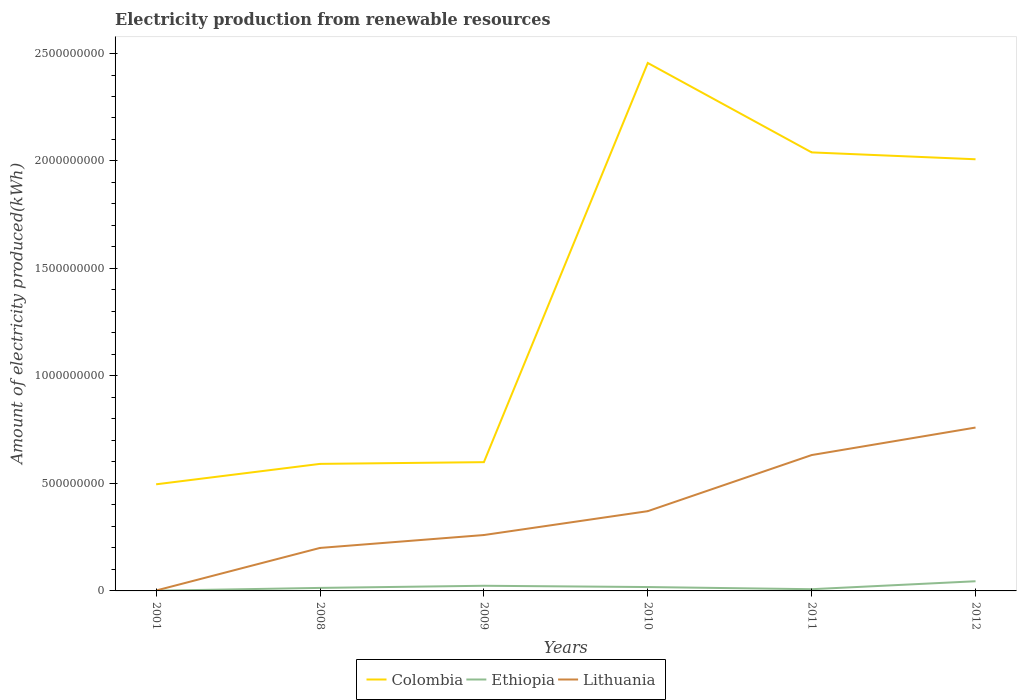How many different coloured lines are there?
Offer a terse response. 3. Does the line corresponding to Ethiopia intersect with the line corresponding to Colombia?
Give a very brief answer. No. Is the number of lines equal to the number of legend labels?
Keep it short and to the point. Yes. Across all years, what is the maximum amount of electricity produced in Colombia?
Your answer should be very brief. 4.96e+08. In which year was the amount of electricity produced in Lithuania maximum?
Offer a terse response. 2001. What is the total amount of electricity produced in Colombia in the graph?
Make the answer very short. -9.50e+07. What is the difference between the highest and the second highest amount of electricity produced in Lithuania?
Ensure brevity in your answer.  7.58e+08. What is the difference between the highest and the lowest amount of electricity produced in Lithuania?
Make the answer very short. 3. Is the amount of electricity produced in Ethiopia strictly greater than the amount of electricity produced in Lithuania over the years?
Keep it short and to the point. Yes. How many years are there in the graph?
Provide a short and direct response. 6. Are the values on the major ticks of Y-axis written in scientific E-notation?
Provide a short and direct response. No. How many legend labels are there?
Your answer should be very brief. 3. How are the legend labels stacked?
Ensure brevity in your answer.  Horizontal. What is the title of the graph?
Keep it short and to the point. Electricity production from renewable resources. Does "Paraguay" appear as one of the legend labels in the graph?
Keep it short and to the point. No. What is the label or title of the Y-axis?
Your answer should be very brief. Amount of electricity produced(kWh). What is the Amount of electricity produced(kWh) in Colombia in 2001?
Offer a very short reply. 4.96e+08. What is the Amount of electricity produced(kWh) of Ethiopia in 2001?
Your answer should be very brief. 1.00e+06. What is the Amount of electricity produced(kWh) in Lithuania in 2001?
Your answer should be very brief. 2.00e+06. What is the Amount of electricity produced(kWh) in Colombia in 2008?
Provide a succinct answer. 5.91e+08. What is the Amount of electricity produced(kWh) in Ethiopia in 2008?
Your answer should be compact. 1.40e+07. What is the Amount of electricity produced(kWh) in Lithuania in 2008?
Ensure brevity in your answer.  2.00e+08. What is the Amount of electricity produced(kWh) in Colombia in 2009?
Provide a short and direct response. 5.99e+08. What is the Amount of electricity produced(kWh) of Ethiopia in 2009?
Offer a terse response. 2.40e+07. What is the Amount of electricity produced(kWh) of Lithuania in 2009?
Offer a terse response. 2.60e+08. What is the Amount of electricity produced(kWh) of Colombia in 2010?
Your answer should be compact. 2.46e+09. What is the Amount of electricity produced(kWh) of Ethiopia in 2010?
Provide a succinct answer. 1.80e+07. What is the Amount of electricity produced(kWh) of Lithuania in 2010?
Your response must be concise. 3.71e+08. What is the Amount of electricity produced(kWh) in Colombia in 2011?
Provide a succinct answer. 2.04e+09. What is the Amount of electricity produced(kWh) of Lithuania in 2011?
Keep it short and to the point. 6.32e+08. What is the Amount of electricity produced(kWh) of Colombia in 2012?
Give a very brief answer. 2.01e+09. What is the Amount of electricity produced(kWh) of Ethiopia in 2012?
Provide a succinct answer. 4.50e+07. What is the Amount of electricity produced(kWh) of Lithuania in 2012?
Your response must be concise. 7.60e+08. Across all years, what is the maximum Amount of electricity produced(kWh) in Colombia?
Provide a short and direct response. 2.46e+09. Across all years, what is the maximum Amount of electricity produced(kWh) in Ethiopia?
Keep it short and to the point. 4.50e+07. Across all years, what is the maximum Amount of electricity produced(kWh) in Lithuania?
Your answer should be very brief. 7.60e+08. Across all years, what is the minimum Amount of electricity produced(kWh) of Colombia?
Keep it short and to the point. 4.96e+08. Across all years, what is the minimum Amount of electricity produced(kWh) of Ethiopia?
Your answer should be compact. 1.00e+06. What is the total Amount of electricity produced(kWh) in Colombia in the graph?
Offer a terse response. 8.19e+09. What is the total Amount of electricity produced(kWh) in Ethiopia in the graph?
Give a very brief answer. 1.10e+08. What is the total Amount of electricity produced(kWh) in Lithuania in the graph?
Provide a short and direct response. 2.22e+09. What is the difference between the Amount of electricity produced(kWh) of Colombia in 2001 and that in 2008?
Offer a very short reply. -9.50e+07. What is the difference between the Amount of electricity produced(kWh) of Ethiopia in 2001 and that in 2008?
Your answer should be compact. -1.30e+07. What is the difference between the Amount of electricity produced(kWh) in Lithuania in 2001 and that in 2008?
Your answer should be very brief. -1.98e+08. What is the difference between the Amount of electricity produced(kWh) in Colombia in 2001 and that in 2009?
Provide a succinct answer. -1.03e+08. What is the difference between the Amount of electricity produced(kWh) in Ethiopia in 2001 and that in 2009?
Make the answer very short. -2.30e+07. What is the difference between the Amount of electricity produced(kWh) in Lithuania in 2001 and that in 2009?
Give a very brief answer. -2.58e+08. What is the difference between the Amount of electricity produced(kWh) of Colombia in 2001 and that in 2010?
Provide a short and direct response. -1.96e+09. What is the difference between the Amount of electricity produced(kWh) in Ethiopia in 2001 and that in 2010?
Provide a short and direct response. -1.70e+07. What is the difference between the Amount of electricity produced(kWh) in Lithuania in 2001 and that in 2010?
Provide a succinct answer. -3.69e+08. What is the difference between the Amount of electricity produced(kWh) of Colombia in 2001 and that in 2011?
Provide a short and direct response. -1.54e+09. What is the difference between the Amount of electricity produced(kWh) of Ethiopia in 2001 and that in 2011?
Ensure brevity in your answer.  -7.00e+06. What is the difference between the Amount of electricity produced(kWh) in Lithuania in 2001 and that in 2011?
Provide a short and direct response. -6.30e+08. What is the difference between the Amount of electricity produced(kWh) in Colombia in 2001 and that in 2012?
Ensure brevity in your answer.  -1.51e+09. What is the difference between the Amount of electricity produced(kWh) of Ethiopia in 2001 and that in 2012?
Ensure brevity in your answer.  -4.40e+07. What is the difference between the Amount of electricity produced(kWh) of Lithuania in 2001 and that in 2012?
Give a very brief answer. -7.58e+08. What is the difference between the Amount of electricity produced(kWh) of Colombia in 2008 and that in 2009?
Make the answer very short. -8.00e+06. What is the difference between the Amount of electricity produced(kWh) of Ethiopia in 2008 and that in 2009?
Your response must be concise. -1.00e+07. What is the difference between the Amount of electricity produced(kWh) of Lithuania in 2008 and that in 2009?
Provide a short and direct response. -6.00e+07. What is the difference between the Amount of electricity produced(kWh) of Colombia in 2008 and that in 2010?
Offer a very short reply. -1.86e+09. What is the difference between the Amount of electricity produced(kWh) of Lithuania in 2008 and that in 2010?
Offer a very short reply. -1.71e+08. What is the difference between the Amount of electricity produced(kWh) in Colombia in 2008 and that in 2011?
Keep it short and to the point. -1.45e+09. What is the difference between the Amount of electricity produced(kWh) of Lithuania in 2008 and that in 2011?
Offer a terse response. -4.32e+08. What is the difference between the Amount of electricity produced(kWh) in Colombia in 2008 and that in 2012?
Offer a terse response. -1.42e+09. What is the difference between the Amount of electricity produced(kWh) of Ethiopia in 2008 and that in 2012?
Your answer should be compact. -3.10e+07. What is the difference between the Amount of electricity produced(kWh) in Lithuania in 2008 and that in 2012?
Give a very brief answer. -5.60e+08. What is the difference between the Amount of electricity produced(kWh) in Colombia in 2009 and that in 2010?
Provide a short and direct response. -1.86e+09. What is the difference between the Amount of electricity produced(kWh) in Lithuania in 2009 and that in 2010?
Provide a short and direct response. -1.11e+08. What is the difference between the Amount of electricity produced(kWh) of Colombia in 2009 and that in 2011?
Make the answer very short. -1.44e+09. What is the difference between the Amount of electricity produced(kWh) of Ethiopia in 2009 and that in 2011?
Offer a terse response. 1.60e+07. What is the difference between the Amount of electricity produced(kWh) in Lithuania in 2009 and that in 2011?
Your answer should be very brief. -3.72e+08. What is the difference between the Amount of electricity produced(kWh) in Colombia in 2009 and that in 2012?
Offer a terse response. -1.41e+09. What is the difference between the Amount of electricity produced(kWh) in Ethiopia in 2009 and that in 2012?
Offer a terse response. -2.10e+07. What is the difference between the Amount of electricity produced(kWh) in Lithuania in 2009 and that in 2012?
Ensure brevity in your answer.  -5.00e+08. What is the difference between the Amount of electricity produced(kWh) of Colombia in 2010 and that in 2011?
Your answer should be very brief. 4.16e+08. What is the difference between the Amount of electricity produced(kWh) in Lithuania in 2010 and that in 2011?
Your response must be concise. -2.61e+08. What is the difference between the Amount of electricity produced(kWh) of Colombia in 2010 and that in 2012?
Offer a terse response. 4.48e+08. What is the difference between the Amount of electricity produced(kWh) of Ethiopia in 2010 and that in 2012?
Ensure brevity in your answer.  -2.70e+07. What is the difference between the Amount of electricity produced(kWh) of Lithuania in 2010 and that in 2012?
Offer a terse response. -3.89e+08. What is the difference between the Amount of electricity produced(kWh) of Colombia in 2011 and that in 2012?
Give a very brief answer. 3.20e+07. What is the difference between the Amount of electricity produced(kWh) in Ethiopia in 2011 and that in 2012?
Your response must be concise. -3.70e+07. What is the difference between the Amount of electricity produced(kWh) of Lithuania in 2011 and that in 2012?
Your answer should be compact. -1.28e+08. What is the difference between the Amount of electricity produced(kWh) of Colombia in 2001 and the Amount of electricity produced(kWh) of Ethiopia in 2008?
Give a very brief answer. 4.82e+08. What is the difference between the Amount of electricity produced(kWh) in Colombia in 2001 and the Amount of electricity produced(kWh) in Lithuania in 2008?
Offer a very short reply. 2.96e+08. What is the difference between the Amount of electricity produced(kWh) in Ethiopia in 2001 and the Amount of electricity produced(kWh) in Lithuania in 2008?
Make the answer very short. -1.99e+08. What is the difference between the Amount of electricity produced(kWh) in Colombia in 2001 and the Amount of electricity produced(kWh) in Ethiopia in 2009?
Give a very brief answer. 4.72e+08. What is the difference between the Amount of electricity produced(kWh) in Colombia in 2001 and the Amount of electricity produced(kWh) in Lithuania in 2009?
Your answer should be very brief. 2.36e+08. What is the difference between the Amount of electricity produced(kWh) in Ethiopia in 2001 and the Amount of electricity produced(kWh) in Lithuania in 2009?
Give a very brief answer. -2.59e+08. What is the difference between the Amount of electricity produced(kWh) of Colombia in 2001 and the Amount of electricity produced(kWh) of Ethiopia in 2010?
Make the answer very short. 4.78e+08. What is the difference between the Amount of electricity produced(kWh) of Colombia in 2001 and the Amount of electricity produced(kWh) of Lithuania in 2010?
Your answer should be compact. 1.25e+08. What is the difference between the Amount of electricity produced(kWh) in Ethiopia in 2001 and the Amount of electricity produced(kWh) in Lithuania in 2010?
Your answer should be compact. -3.70e+08. What is the difference between the Amount of electricity produced(kWh) of Colombia in 2001 and the Amount of electricity produced(kWh) of Ethiopia in 2011?
Your response must be concise. 4.88e+08. What is the difference between the Amount of electricity produced(kWh) in Colombia in 2001 and the Amount of electricity produced(kWh) in Lithuania in 2011?
Ensure brevity in your answer.  -1.36e+08. What is the difference between the Amount of electricity produced(kWh) of Ethiopia in 2001 and the Amount of electricity produced(kWh) of Lithuania in 2011?
Ensure brevity in your answer.  -6.31e+08. What is the difference between the Amount of electricity produced(kWh) of Colombia in 2001 and the Amount of electricity produced(kWh) of Ethiopia in 2012?
Give a very brief answer. 4.51e+08. What is the difference between the Amount of electricity produced(kWh) of Colombia in 2001 and the Amount of electricity produced(kWh) of Lithuania in 2012?
Your response must be concise. -2.64e+08. What is the difference between the Amount of electricity produced(kWh) of Ethiopia in 2001 and the Amount of electricity produced(kWh) of Lithuania in 2012?
Provide a succinct answer. -7.59e+08. What is the difference between the Amount of electricity produced(kWh) in Colombia in 2008 and the Amount of electricity produced(kWh) in Ethiopia in 2009?
Give a very brief answer. 5.67e+08. What is the difference between the Amount of electricity produced(kWh) of Colombia in 2008 and the Amount of electricity produced(kWh) of Lithuania in 2009?
Give a very brief answer. 3.31e+08. What is the difference between the Amount of electricity produced(kWh) in Ethiopia in 2008 and the Amount of electricity produced(kWh) in Lithuania in 2009?
Offer a terse response. -2.46e+08. What is the difference between the Amount of electricity produced(kWh) of Colombia in 2008 and the Amount of electricity produced(kWh) of Ethiopia in 2010?
Your answer should be very brief. 5.73e+08. What is the difference between the Amount of electricity produced(kWh) in Colombia in 2008 and the Amount of electricity produced(kWh) in Lithuania in 2010?
Your answer should be compact. 2.20e+08. What is the difference between the Amount of electricity produced(kWh) in Ethiopia in 2008 and the Amount of electricity produced(kWh) in Lithuania in 2010?
Give a very brief answer. -3.57e+08. What is the difference between the Amount of electricity produced(kWh) in Colombia in 2008 and the Amount of electricity produced(kWh) in Ethiopia in 2011?
Your response must be concise. 5.83e+08. What is the difference between the Amount of electricity produced(kWh) of Colombia in 2008 and the Amount of electricity produced(kWh) of Lithuania in 2011?
Make the answer very short. -4.10e+07. What is the difference between the Amount of electricity produced(kWh) of Ethiopia in 2008 and the Amount of electricity produced(kWh) of Lithuania in 2011?
Give a very brief answer. -6.18e+08. What is the difference between the Amount of electricity produced(kWh) in Colombia in 2008 and the Amount of electricity produced(kWh) in Ethiopia in 2012?
Offer a terse response. 5.46e+08. What is the difference between the Amount of electricity produced(kWh) of Colombia in 2008 and the Amount of electricity produced(kWh) of Lithuania in 2012?
Make the answer very short. -1.69e+08. What is the difference between the Amount of electricity produced(kWh) of Ethiopia in 2008 and the Amount of electricity produced(kWh) of Lithuania in 2012?
Make the answer very short. -7.46e+08. What is the difference between the Amount of electricity produced(kWh) in Colombia in 2009 and the Amount of electricity produced(kWh) in Ethiopia in 2010?
Your response must be concise. 5.81e+08. What is the difference between the Amount of electricity produced(kWh) of Colombia in 2009 and the Amount of electricity produced(kWh) of Lithuania in 2010?
Ensure brevity in your answer.  2.28e+08. What is the difference between the Amount of electricity produced(kWh) of Ethiopia in 2009 and the Amount of electricity produced(kWh) of Lithuania in 2010?
Provide a short and direct response. -3.47e+08. What is the difference between the Amount of electricity produced(kWh) in Colombia in 2009 and the Amount of electricity produced(kWh) in Ethiopia in 2011?
Offer a terse response. 5.91e+08. What is the difference between the Amount of electricity produced(kWh) in Colombia in 2009 and the Amount of electricity produced(kWh) in Lithuania in 2011?
Make the answer very short. -3.30e+07. What is the difference between the Amount of electricity produced(kWh) in Ethiopia in 2009 and the Amount of electricity produced(kWh) in Lithuania in 2011?
Keep it short and to the point. -6.08e+08. What is the difference between the Amount of electricity produced(kWh) in Colombia in 2009 and the Amount of electricity produced(kWh) in Ethiopia in 2012?
Your answer should be very brief. 5.54e+08. What is the difference between the Amount of electricity produced(kWh) of Colombia in 2009 and the Amount of electricity produced(kWh) of Lithuania in 2012?
Your response must be concise. -1.61e+08. What is the difference between the Amount of electricity produced(kWh) in Ethiopia in 2009 and the Amount of electricity produced(kWh) in Lithuania in 2012?
Keep it short and to the point. -7.36e+08. What is the difference between the Amount of electricity produced(kWh) in Colombia in 2010 and the Amount of electricity produced(kWh) in Ethiopia in 2011?
Make the answer very short. 2.45e+09. What is the difference between the Amount of electricity produced(kWh) in Colombia in 2010 and the Amount of electricity produced(kWh) in Lithuania in 2011?
Make the answer very short. 1.82e+09. What is the difference between the Amount of electricity produced(kWh) of Ethiopia in 2010 and the Amount of electricity produced(kWh) of Lithuania in 2011?
Keep it short and to the point. -6.14e+08. What is the difference between the Amount of electricity produced(kWh) of Colombia in 2010 and the Amount of electricity produced(kWh) of Ethiopia in 2012?
Ensure brevity in your answer.  2.41e+09. What is the difference between the Amount of electricity produced(kWh) in Colombia in 2010 and the Amount of electricity produced(kWh) in Lithuania in 2012?
Provide a succinct answer. 1.70e+09. What is the difference between the Amount of electricity produced(kWh) of Ethiopia in 2010 and the Amount of electricity produced(kWh) of Lithuania in 2012?
Your response must be concise. -7.42e+08. What is the difference between the Amount of electricity produced(kWh) in Colombia in 2011 and the Amount of electricity produced(kWh) in Ethiopia in 2012?
Your response must be concise. 2.00e+09. What is the difference between the Amount of electricity produced(kWh) in Colombia in 2011 and the Amount of electricity produced(kWh) in Lithuania in 2012?
Your answer should be very brief. 1.28e+09. What is the difference between the Amount of electricity produced(kWh) in Ethiopia in 2011 and the Amount of electricity produced(kWh) in Lithuania in 2012?
Your response must be concise. -7.52e+08. What is the average Amount of electricity produced(kWh) in Colombia per year?
Give a very brief answer. 1.36e+09. What is the average Amount of electricity produced(kWh) of Ethiopia per year?
Offer a terse response. 1.83e+07. What is the average Amount of electricity produced(kWh) in Lithuania per year?
Your answer should be compact. 3.71e+08. In the year 2001, what is the difference between the Amount of electricity produced(kWh) of Colombia and Amount of electricity produced(kWh) of Ethiopia?
Give a very brief answer. 4.95e+08. In the year 2001, what is the difference between the Amount of electricity produced(kWh) in Colombia and Amount of electricity produced(kWh) in Lithuania?
Your answer should be very brief. 4.94e+08. In the year 2001, what is the difference between the Amount of electricity produced(kWh) in Ethiopia and Amount of electricity produced(kWh) in Lithuania?
Offer a very short reply. -1.00e+06. In the year 2008, what is the difference between the Amount of electricity produced(kWh) in Colombia and Amount of electricity produced(kWh) in Ethiopia?
Keep it short and to the point. 5.77e+08. In the year 2008, what is the difference between the Amount of electricity produced(kWh) in Colombia and Amount of electricity produced(kWh) in Lithuania?
Ensure brevity in your answer.  3.91e+08. In the year 2008, what is the difference between the Amount of electricity produced(kWh) in Ethiopia and Amount of electricity produced(kWh) in Lithuania?
Make the answer very short. -1.86e+08. In the year 2009, what is the difference between the Amount of electricity produced(kWh) in Colombia and Amount of electricity produced(kWh) in Ethiopia?
Your response must be concise. 5.75e+08. In the year 2009, what is the difference between the Amount of electricity produced(kWh) in Colombia and Amount of electricity produced(kWh) in Lithuania?
Your answer should be compact. 3.39e+08. In the year 2009, what is the difference between the Amount of electricity produced(kWh) of Ethiopia and Amount of electricity produced(kWh) of Lithuania?
Offer a very short reply. -2.36e+08. In the year 2010, what is the difference between the Amount of electricity produced(kWh) of Colombia and Amount of electricity produced(kWh) of Ethiopia?
Ensure brevity in your answer.  2.44e+09. In the year 2010, what is the difference between the Amount of electricity produced(kWh) of Colombia and Amount of electricity produced(kWh) of Lithuania?
Keep it short and to the point. 2.08e+09. In the year 2010, what is the difference between the Amount of electricity produced(kWh) of Ethiopia and Amount of electricity produced(kWh) of Lithuania?
Offer a very short reply. -3.53e+08. In the year 2011, what is the difference between the Amount of electricity produced(kWh) in Colombia and Amount of electricity produced(kWh) in Ethiopia?
Provide a short and direct response. 2.03e+09. In the year 2011, what is the difference between the Amount of electricity produced(kWh) of Colombia and Amount of electricity produced(kWh) of Lithuania?
Your response must be concise. 1.41e+09. In the year 2011, what is the difference between the Amount of electricity produced(kWh) of Ethiopia and Amount of electricity produced(kWh) of Lithuania?
Provide a short and direct response. -6.24e+08. In the year 2012, what is the difference between the Amount of electricity produced(kWh) of Colombia and Amount of electricity produced(kWh) of Ethiopia?
Offer a terse response. 1.96e+09. In the year 2012, what is the difference between the Amount of electricity produced(kWh) of Colombia and Amount of electricity produced(kWh) of Lithuania?
Offer a very short reply. 1.25e+09. In the year 2012, what is the difference between the Amount of electricity produced(kWh) in Ethiopia and Amount of electricity produced(kWh) in Lithuania?
Your answer should be very brief. -7.15e+08. What is the ratio of the Amount of electricity produced(kWh) in Colombia in 2001 to that in 2008?
Provide a succinct answer. 0.84. What is the ratio of the Amount of electricity produced(kWh) in Ethiopia in 2001 to that in 2008?
Ensure brevity in your answer.  0.07. What is the ratio of the Amount of electricity produced(kWh) of Colombia in 2001 to that in 2009?
Make the answer very short. 0.83. What is the ratio of the Amount of electricity produced(kWh) in Ethiopia in 2001 to that in 2009?
Ensure brevity in your answer.  0.04. What is the ratio of the Amount of electricity produced(kWh) of Lithuania in 2001 to that in 2009?
Your response must be concise. 0.01. What is the ratio of the Amount of electricity produced(kWh) in Colombia in 2001 to that in 2010?
Provide a short and direct response. 0.2. What is the ratio of the Amount of electricity produced(kWh) in Ethiopia in 2001 to that in 2010?
Your response must be concise. 0.06. What is the ratio of the Amount of electricity produced(kWh) in Lithuania in 2001 to that in 2010?
Give a very brief answer. 0.01. What is the ratio of the Amount of electricity produced(kWh) of Colombia in 2001 to that in 2011?
Give a very brief answer. 0.24. What is the ratio of the Amount of electricity produced(kWh) in Lithuania in 2001 to that in 2011?
Keep it short and to the point. 0. What is the ratio of the Amount of electricity produced(kWh) of Colombia in 2001 to that in 2012?
Provide a short and direct response. 0.25. What is the ratio of the Amount of electricity produced(kWh) in Ethiopia in 2001 to that in 2012?
Your answer should be compact. 0.02. What is the ratio of the Amount of electricity produced(kWh) in Lithuania in 2001 to that in 2012?
Provide a short and direct response. 0. What is the ratio of the Amount of electricity produced(kWh) in Colombia in 2008 to that in 2009?
Your response must be concise. 0.99. What is the ratio of the Amount of electricity produced(kWh) of Ethiopia in 2008 to that in 2009?
Keep it short and to the point. 0.58. What is the ratio of the Amount of electricity produced(kWh) of Lithuania in 2008 to that in 2009?
Provide a succinct answer. 0.77. What is the ratio of the Amount of electricity produced(kWh) in Colombia in 2008 to that in 2010?
Provide a succinct answer. 0.24. What is the ratio of the Amount of electricity produced(kWh) in Lithuania in 2008 to that in 2010?
Offer a terse response. 0.54. What is the ratio of the Amount of electricity produced(kWh) in Colombia in 2008 to that in 2011?
Offer a terse response. 0.29. What is the ratio of the Amount of electricity produced(kWh) of Ethiopia in 2008 to that in 2011?
Provide a succinct answer. 1.75. What is the ratio of the Amount of electricity produced(kWh) in Lithuania in 2008 to that in 2011?
Offer a terse response. 0.32. What is the ratio of the Amount of electricity produced(kWh) of Colombia in 2008 to that in 2012?
Ensure brevity in your answer.  0.29. What is the ratio of the Amount of electricity produced(kWh) in Ethiopia in 2008 to that in 2012?
Offer a very short reply. 0.31. What is the ratio of the Amount of electricity produced(kWh) of Lithuania in 2008 to that in 2012?
Your answer should be very brief. 0.26. What is the ratio of the Amount of electricity produced(kWh) of Colombia in 2009 to that in 2010?
Make the answer very short. 0.24. What is the ratio of the Amount of electricity produced(kWh) in Lithuania in 2009 to that in 2010?
Make the answer very short. 0.7. What is the ratio of the Amount of electricity produced(kWh) of Colombia in 2009 to that in 2011?
Offer a very short reply. 0.29. What is the ratio of the Amount of electricity produced(kWh) in Lithuania in 2009 to that in 2011?
Your answer should be very brief. 0.41. What is the ratio of the Amount of electricity produced(kWh) of Colombia in 2009 to that in 2012?
Offer a terse response. 0.3. What is the ratio of the Amount of electricity produced(kWh) of Ethiopia in 2009 to that in 2012?
Make the answer very short. 0.53. What is the ratio of the Amount of electricity produced(kWh) of Lithuania in 2009 to that in 2012?
Your answer should be compact. 0.34. What is the ratio of the Amount of electricity produced(kWh) in Colombia in 2010 to that in 2011?
Keep it short and to the point. 1.2. What is the ratio of the Amount of electricity produced(kWh) of Ethiopia in 2010 to that in 2011?
Offer a very short reply. 2.25. What is the ratio of the Amount of electricity produced(kWh) in Lithuania in 2010 to that in 2011?
Your answer should be compact. 0.59. What is the ratio of the Amount of electricity produced(kWh) of Colombia in 2010 to that in 2012?
Your response must be concise. 1.22. What is the ratio of the Amount of electricity produced(kWh) of Lithuania in 2010 to that in 2012?
Keep it short and to the point. 0.49. What is the ratio of the Amount of electricity produced(kWh) in Colombia in 2011 to that in 2012?
Keep it short and to the point. 1.02. What is the ratio of the Amount of electricity produced(kWh) in Ethiopia in 2011 to that in 2012?
Your answer should be very brief. 0.18. What is the ratio of the Amount of electricity produced(kWh) in Lithuania in 2011 to that in 2012?
Your answer should be compact. 0.83. What is the difference between the highest and the second highest Amount of electricity produced(kWh) in Colombia?
Give a very brief answer. 4.16e+08. What is the difference between the highest and the second highest Amount of electricity produced(kWh) of Ethiopia?
Make the answer very short. 2.10e+07. What is the difference between the highest and the second highest Amount of electricity produced(kWh) in Lithuania?
Ensure brevity in your answer.  1.28e+08. What is the difference between the highest and the lowest Amount of electricity produced(kWh) in Colombia?
Offer a very short reply. 1.96e+09. What is the difference between the highest and the lowest Amount of electricity produced(kWh) in Ethiopia?
Your response must be concise. 4.40e+07. What is the difference between the highest and the lowest Amount of electricity produced(kWh) in Lithuania?
Provide a succinct answer. 7.58e+08. 